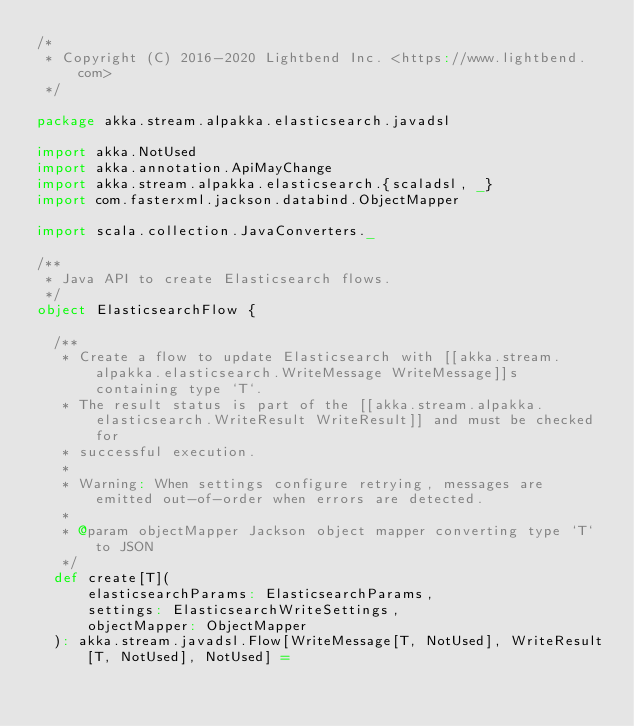<code> <loc_0><loc_0><loc_500><loc_500><_Scala_>/*
 * Copyright (C) 2016-2020 Lightbend Inc. <https://www.lightbend.com>
 */

package akka.stream.alpakka.elasticsearch.javadsl

import akka.NotUsed
import akka.annotation.ApiMayChange
import akka.stream.alpakka.elasticsearch.{scaladsl, _}
import com.fasterxml.jackson.databind.ObjectMapper

import scala.collection.JavaConverters._

/**
 * Java API to create Elasticsearch flows.
 */
object ElasticsearchFlow {

  /**
   * Create a flow to update Elasticsearch with [[akka.stream.alpakka.elasticsearch.WriteMessage WriteMessage]]s containing type `T`.
   * The result status is part of the [[akka.stream.alpakka.elasticsearch.WriteResult WriteResult]] and must be checked for
   * successful execution.
   *
   * Warning: When settings configure retrying, messages are emitted out-of-order when errors are detected.
   *
   * @param objectMapper Jackson object mapper converting type `T` to JSON
   */
  def create[T](
      elasticsearchParams: ElasticsearchParams,
      settings: ElasticsearchWriteSettings,
      objectMapper: ObjectMapper
  ): akka.stream.javadsl.Flow[WriteMessage[T, NotUsed], WriteResult[T, NotUsed], NotUsed] =</code> 